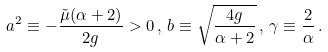Convert formula to latex. <formula><loc_0><loc_0><loc_500><loc_500>a ^ { 2 } \equiv - \frac { \tilde { \mu } ( \alpha + 2 ) } { 2 g } > 0 \, , \, b \equiv \sqrt { \frac { 4 g } { \alpha + 2 } } \, , \, \gamma \equiv \frac { 2 } { \alpha } \, .</formula> 